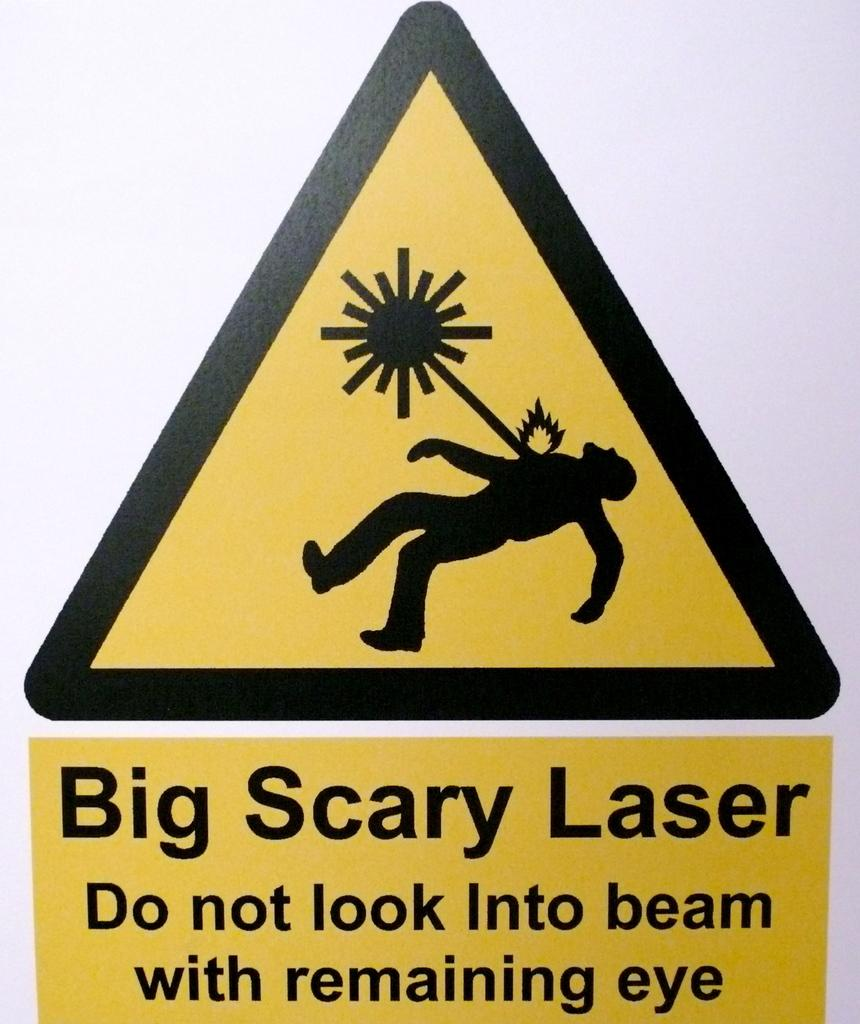<image>
Summarize the visual content of the image. a big scary laser sign that has a graphic on it 